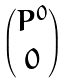<formula> <loc_0><loc_0><loc_500><loc_500>\begin{pmatrix} P ^ { 0 } \\ 0 \end{pmatrix}</formula> 